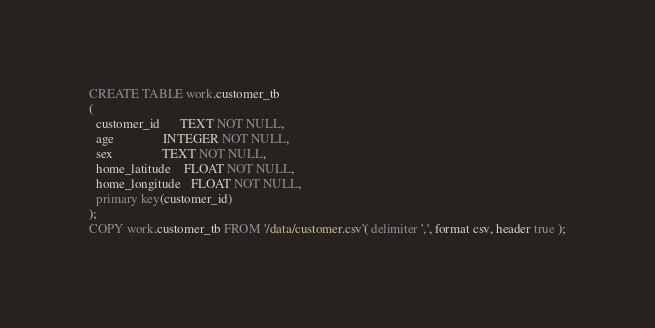Convert code to text. <code><loc_0><loc_0><loc_500><loc_500><_SQL_>CREATE TABLE work.customer_tb
(
  customer_id      TEXT NOT NULL,
  age         	   INTEGER NOT NULL,
  sex      		   TEXT NOT NULL,
  home_latitude    FLOAT NOT NULL,
  home_longitude   FLOAT NOT NULL,
  primary key(customer_id)
);
COPY work.customer_tb FROM '/data/customer.csv'( delimiter ',', format csv, header true );
</code> 